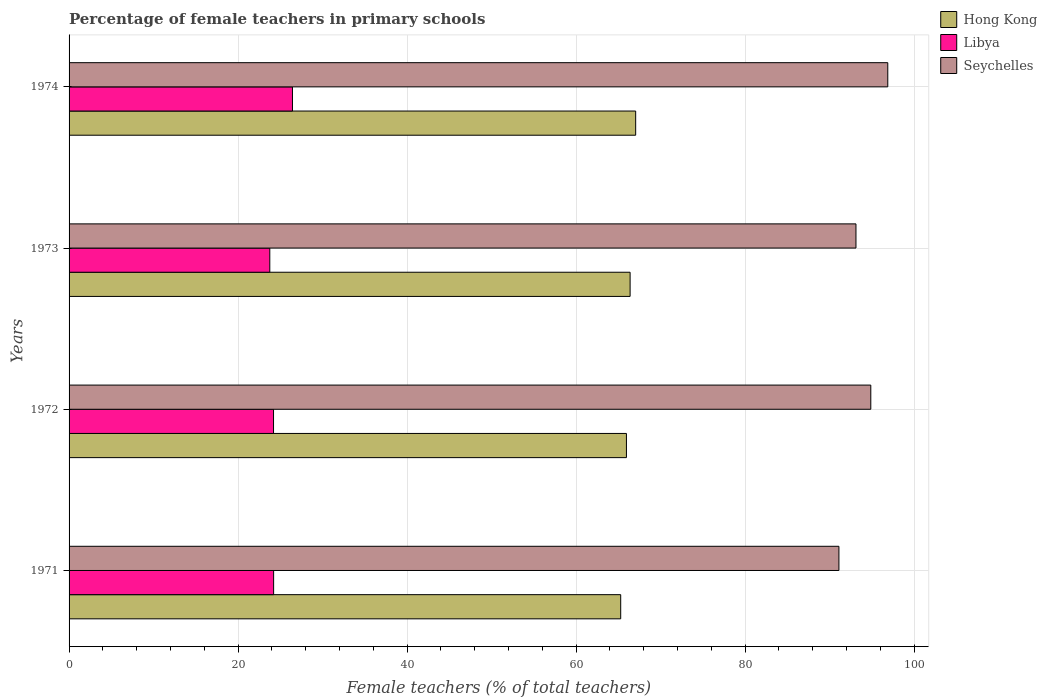How many different coloured bars are there?
Give a very brief answer. 3. How many groups of bars are there?
Provide a short and direct response. 4. Are the number of bars per tick equal to the number of legend labels?
Offer a very short reply. Yes. How many bars are there on the 2nd tick from the top?
Make the answer very short. 3. What is the label of the 1st group of bars from the top?
Your answer should be compact. 1974. What is the percentage of female teachers in Hong Kong in 1974?
Your answer should be very brief. 67.04. Across all years, what is the maximum percentage of female teachers in Libya?
Ensure brevity in your answer.  26.43. Across all years, what is the minimum percentage of female teachers in Seychelles?
Provide a short and direct response. 91.09. In which year was the percentage of female teachers in Seychelles maximum?
Provide a succinct answer. 1974. What is the total percentage of female teachers in Hong Kong in the graph?
Provide a short and direct response. 264.65. What is the difference between the percentage of female teachers in Hong Kong in 1971 and that in 1974?
Give a very brief answer. -1.77. What is the difference between the percentage of female teachers in Seychelles in 1971 and the percentage of female teachers in Libya in 1972?
Your answer should be compact. 66.9. What is the average percentage of female teachers in Seychelles per year?
Ensure brevity in your answer.  93.99. In the year 1973, what is the difference between the percentage of female teachers in Seychelles and percentage of female teachers in Libya?
Your response must be concise. 69.36. In how many years, is the percentage of female teachers in Seychelles greater than 72 %?
Provide a short and direct response. 4. What is the ratio of the percentage of female teachers in Seychelles in 1972 to that in 1974?
Your answer should be very brief. 0.98. Is the difference between the percentage of female teachers in Seychelles in 1971 and 1973 greater than the difference between the percentage of female teachers in Libya in 1971 and 1973?
Provide a short and direct response. No. What is the difference between the highest and the second highest percentage of female teachers in Seychelles?
Give a very brief answer. 2.01. What is the difference between the highest and the lowest percentage of female teachers in Hong Kong?
Offer a terse response. 1.77. In how many years, is the percentage of female teachers in Hong Kong greater than the average percentage of female teachers in Hong Kong taken over all years?
Provide a short and direct response. 2. Is the sum of the percentage of female teachers in Seychelles in 1972 and 1974 greater than the maximum percentage of female teachers in Hong Kong across all years?
Provide a short and direct response. Yes. What does the 3rd bar from the top in 1973 represents?
Provide a succinct answer. Hong Kong. What does the 2nd bar from the bottom in 1974 represents?
Your response must be concise. Libya. How many bars are there?
Make the answer very short. 12. How many years are there in the graph?
Provide a succinct answer. 4. Does the graph contain any zero values?
Your response must be concise. No. Does the graph contain grids?
Provide a short and direct response. Yes. Where does the legend appear in the graph?
Keep it short and to the point. Top right. How many legend labels are there?
Provide a short and direct response. 3. How are the legend labels stacked?
Ensure brevity in your answer.  Vertical. What is the title of the graph?
Offer a very short reply. Percentage of female teachers in primary schools. Does "India" appear as one of the legend labels in the graph?
Your answer should be compact. No. What is the label or title of the X-axis?
Your answer should be very brief. Female teachers (% of total teachers). What is the label or title of the Y-axis?
Offer a terse response. Years. What is the Female teachers (% of total teachers) of Hong Kong in 1971?
Ensure brevity in your answer.  65.27. What is the Female teachers (% of total teachers) in Libya in 1971?
Make the answer very short. 24.2. What is the Female teachers (% of total teachers) of Seychelles in 1971?
Ensure brevity in your answer.  91.09. What is the Female teachers (% of total teachers) in Hong Kong in 1972?
Your answer should be very brief. 65.95. What is the Female teachers (% of total teachers) of Libya in 1972?
Keep it short and to the point. 24.19. What is the Female teachers (% of total teachers) in Seychelles in 1972?
Make the answer very short. 94.87. What is the Female teachers (% of total teachers) in Hong Kong in 1973?
Provide a succinct answer. 66.39. What is the Female teachers (% of total teachers) in Libya in 1973?
Your response must be concise. 23.75. What is the Female teachers (% of total teachers) of Seychelles in 1973?
Your answer should be very brief. 93.11. What is the Female teachers (% of total teachers) in Hong Kong in 1974?
Ensure brevity in your answer.  67.04. What is the Female teachers (% of total teachers) of Libya in 1974?
Provide a short and direct response. 26.43. What is the Female teachers (% of total teachers) in Seychelles in 1974?
Offer a very short reply. 96.88. Across all years, what is the maximum Female teachers (% of total teachers) of Hong Kong?
Offer a terse response. 67.04. Across all years, what is the maximum Female teachers (% of total teachers) in Libya?
Provide a short and direct response. 26.43. Across all years, what is the maximum Female teachers (% of total teachers) of Seychelles?
Your response must be concise. 96.88. Across all years, what is the minimum Female teachers (% of total teachers) in Hong Kong?
Your response must be concise. 65.27. Across all years, what is the minimum Female teachers (% of total teachers) of Libya?
Your response must be concise. 23.75. Across all years, what is the minimum Female teachers (% of total teachers) in Seychelles?
Your answer should be very brief. 91.09. What is the total Female teachers (% of total teachers) in Hong Kong in the graph?
Offer a very short reply. 264.65. What is the total Female teachers (% of total teachers) of Libya in the graph?
Offer a terse response. 98.58. What is the total Female teachers (% of total teachers) of Seychelles in the graph?
Keep it short and to the point. 375.95. What is the difference between the Female teachers (% of total teachers) in Hong Kong in 1971 and that in 1972?
Make the answer very short. -0.68. What is the difference between the Female teachers (% of total teachers) of Libya in 1971 and that in 1972?
Give a very brief answer. 0.01. What is the difference between the Female teachers (% of total teachers) of Seychelles in 1971 and that in 1972?
Ensure brevity in your answer.  -3.77. What is the difference between the Female teachers (% of total teachers) in Hong Kong in 1971 and that in 1973?
Your response must be concise. -1.11. What is the difference between the Female teachers (% of total teachers) of Libya in 1971 and that in 1973?
Your answer should be compact. 0.45. What is the difference between the Female teachers (% of total teachers) in Seychelles in 1971 and that in 1973?
Give a very brief answer. -2.02. What is the difference between the Female teachers (% of total teachers) in Hong Kong in 1971 and that in 1974?
Offer a very short reply. -1.77. What is the difference between the Female teachers (% of total teachers) of Libya in 1971 and that in 1974?
Your answer should be compact. -2.23. What is the difference between the Female teachers (% of total teachers) of Seychelles in 1971 and that in 1974?
Provide a short and direct response. -5.78. What is the difference between the Female teachers (% of total teachers) of Hong Kong in 1972 and that in 1973?
Your answer should be compact. -0.43. What is the difference between the Female teachers (% of total teachers) of Libya in 1972 and that in 1973?
Give a very brief answer. 0.44. What is the difference between the Female teachers (% of total teachers) in Seychelles in 1972 and that in 1973?
Offer a terse response. 1.75. What is the difference between the Female teachers (% of total teachers) of Hong Kong in 1972 and that in 1974?
Provide a succinct answer. -1.09. What is the difference between the Female teachers (% of total teachers) in Libya in 1972 and that in 1974?
Your answer should be very brief. -2.24. What is the difference between the Female teachers (% of total teachers) in Seychelles in 1972 and that in 1974?
Keep it short and to the point. -2.01. What is the difference between the Female teachers (% of total teachers) of Hong Kong in 1973 and that in 1974?
Your response must be concise. -0.66. What is the difference between the Female teachers (% of total teachers) of Libya in 1973 and that in 1974?
Make the answer very short. -2.68. What is the difference between the Female teachers (% of total teachers) of Seychelles in 1973 and that in 1974?
Offer a terse response. -3.76. What is the difference between the Female teachers (% of total teachers) in Hong Kong in 1971 and the Female teachers (% of total teachers) in Libya in 1972?
Offer a very short reply. 41.08. What is the difference between the Female teachers (% of total teachers) of Hong Kong in 1971 and the Female teachers (% of total teachers) of Seychelles in 1972?
Your response must be concise. -29.59. What is the difference between the Female teachers (% of total teachers) in Libya in 1971 and the Female teachers (% of total teachers) in Seychelles in 1972?
Your answer should be very brief. -70.66. What is the difference between the Female teachers (% of total teachers) in Hong Kong in 1971 and the Female teachers (% of total teachers) in Libya in 1973?
Your answer should be compact. 41.52. What is the difference between the Female teachers (% of total teachers) of Hong Kong in 1971 and the Female teachers (% of total teachers) of Seychelles in 1973?
Provide a succinct answer. -27.84. What is the difference between the Female teachers (% of total teachers) in Libya in 1971 and the Female teachers (% of total teachers) in Seychelles in 1973?
Ensure brevity in your answer.  -68.91. What is the difference between the Female teachers (% of total teachers) in Hong Kong in 1971 and the Female teachers (% of total teachers) in Libya in 1974?
Offer a very short reply. 38.84. What is the difference between the Female teachers (% of total teachers) of Hong Kong in 1971 and the Female teachers (% of total teachers) of Seychelles in 1974?
Your answer should be compact. -31.6. What is the difference between the Female teachers (% of total teachers) in Libya in 1971 and the Female teachers (% of total teachers) in Seychelles in 1974?
Your answer should be very brief. -72.67. What is the difference between the Female teachers (% of total teachers) in Hong Kong in 1972 and the Female teachers (% of total teachers) in Libya in 1973?
Ensure brevity in your answer.  42.2. What is the difference between the Female teachers (% of total teachers) of Hong Kong in 1972 and the Female teachers (% of total teachers) of Seychelles in 1973?
Provide a succinct answer. -27.16. What is the difference between the Female teachers (% of total teachers) of Libya in 1972 and the Female teachers (% of total teachers) of Seychelles in 1973?
Offer a very short reply. -68.92. What is the difference between the Female teachers (% of total teachers) in Hong Kong in 1972 and the Female teachers (% of total teachers) in Libya in 1974?
Provide a succinct answer. 39.52. What is the difference between the Female teachers (% of total teachers) in Hong Kong in 1972 and the Female teachers (% of total teachers) in Seychelles in 1974?
Your response must be concise. -30.92. What is the difference between the Female teachers (% of total teachers) in Libya in 1972 and the Female teachers (% of total teachers) in Seychelles in 1974?
Provide a succinct answer. -72.68. What is the difference between the Female teachers (% of total teachers) of Hong Kong in 1973 and the Female teachers (% of total teachers) of Libya in 1974?
Offer a very short reply. 39.95. What is the difference between the Female teachers (% of total teachers) in Hong Kong in 1973 and the Female teachers (% of total teachers) in Seychelles in 1974?
Your answer should be compact. -30.49. What is the difference between the Female teachers (% of total teachers) of Libya in 1973 and the Female teachers (% of total teachers) of Seychelles in 1974?
Ensure brevity in your answer.  -73.12. What is the average Female teachers (% of total teachers) in Hong Kong per year?
Your response must be concise. 66.16. What is the average Female teachers (% of total teachers) of Libya per year?
Make the answer very short. 24.65. What is the average Female teachers (% of total teachers) in Seychelles per year?
Make the answer very short. 93.99. In the year 1971, what is the difference between the Female teachers (% of total teachers) in Hong Kong and Female teachers (% of total teachers) in Libya?
Keep it short and to the point. 41.07. In the year 1971, what is the difference between the Female teachers (% of total teachers) in Hong Kong and Female teachers (% of total teachers) in Seychelles?
Your answer should be compact. -25.82. In the year 1971, what is the difference between the Female teachers (% of total teachers) in Libya and Female teachers (% of total teachers) in Seychelles?
Your response must be concise. -66.89. In the year 1972, what is the difference between the Female teachers (% of total teachers) in Hong Kong and Female teachers (% of total teachers) in Libya?
Offer a very short reply. 41.76. In the year 1972, what is the difference between the Female teachers (% of total teachers) in Hong Kong and Female teachers (% of total teachers) in Seychelles?
Your response must be concise. -28.91. In the year 1972, what is the difference between the Female teachers (% of total teachers) of Libya and Female teachers (% of total teachers) of Seychelles?
Ensure brevity in your answer.  -70.67. In the year 1973, what is the difference between the Female teachers (% of total teachers) of Hong Kong and Female teachers (% of total teachers) of Libya?
Provide a short and direct response. 42.63. In the year 1973, what is the difference between the Female teachers (% of total teachers) of Hong Kong and Female teachers (% of total teachers) of Seychelles?
Make the answer very short. -26.73. In the year 1973, what is the difference between the Female teachers (% of total teachers) in Libya and Female teachers (% of total teachers) in Seychelles?
Provide a short and direct response. -69.36. In the year 1974, what is the difference between the Female teachers (% of total teachers) in Hong Kong and Female teachers (% of total teachers) in Libya?
Your answer should be compact. 40.61. In the year 1974, what is the difference between the Female teachers (% of total teachers) in Hong Kong and Female teachers (% of total teachers) in Seychelles?
Your answer should be very brief. -29.83. In the year 1974, what is the difference between the Female teachers (% of total teachers) of Libya and Female teachers (% of total teachers) of Seychelles?
Your answer should be very brief. -70.44. What is the ratio of the Female teachers (% of total teachers) in Seychelles in 1971 to that in 1972?
Ensure brevity in your answer.  0.96. What is the ratio of the Female teachers (% of total teachers) in Hong Kong in 1971 to that in 1973?
Your answer should be compact. 0.98. What is the ratio of the Female teachers (% of total teachers) in Seychelles in 1971 to that in 1973?
Your response must be concise. 0.98. What is the ratio of the Female teachers (% of total teachers) of Hong Kong in 1971 to that in 1974?
Your answer should be very brief. 0.97. What is the ratio of the Female teachers (% of total teachers) of Libya in 1971 to that in 1974?
Keep it short and to the point. 0.92. What is the ratio of the Female teachers (% of total teachers) in Seychelles in 1971 to that in 1974?
Your response must be concise. 0.94. What is the ratio of the Female teachers (% of total teachers) of Hong Kong in 1972 to that in 1973?
Ensure brevity in your answer.  0.99. What is the ratio of the Female teachers (% of total teachers) in Libya in 1972 to that in 1973?
Offer a very short reply. 1.02. What is the ratio of the Female teachers (% of total teachers) in Seychelles in 1972 to that in 1973?
Make the answer very short. 1.02. What is the ratio of the Female teachers (% of total teachers) in Hong Kong in 1972 to that in 1974?
Your answer should be very brief. 0.98. What is the ratio of the Female teachers (% of total teachers) in Libya in 1972 to that in 1974?
Your response must be concise. 0.92. What is the ratio of the Female teachers (% of total teachers) in Seychelles in 1972 to that in 1974?
Provide a short and direct response. 0.98. What is the ratio of the Female teachers (% of total teachers) of Hong Kong in 1973 to that in 1974?
Your answer should be very brief. 0.99. What is the ratio of the Female teachers (% of total teachers) of Libya in 1973 to that in 1974?
Offer a terse response. 0.9. What is the ratio of the Female teachers (% of total teachers) in Seychelles in 1973 to that in 1974?
Keep it short and to the point. 0.96. What is the difference between the highest and the second highest Female teachers (% of total teachers) in Hong Kong?
Your response must be concise. 0.66. What is the difference between the highest and the second highest Female teachers (% of total teachers) of Libya?
Your response must be concise. 2.23. What is the difference between the highest and the second highest Female teachers (% of total teachers) in Seychelles?
Ensure brevity in your answer.  2.01. What is the difference between the highest and the lowest Female teachers (% of total teachers) of Hong Kong?
Your answer should be compact. 1.77. What is the difference between the highest and the lowest Female teachers (% of total teachers) in Libya?
Your response must be concise. 2.68. What is the difference between the highest and the lowest Female teachers (% of total teachers) in Seychelles?
Provide a succinct answer. 5.78. 